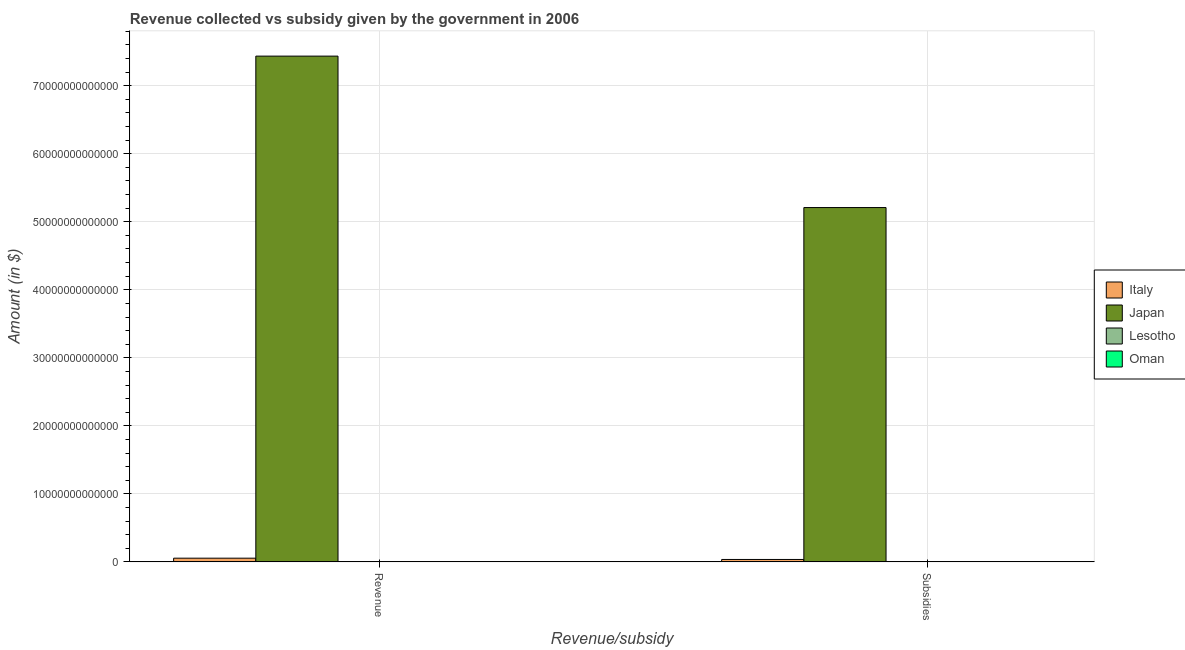How many different coloured bars are there?
Offer a terse response. 4. How many groups of bars are there?
Keep it short and to the point. 2. How many bars are there on the 1st tick from the left?
Offer a very short reply. 4. What is the label of the 1st group of bars from the left?
Offer a terse response. Revenue. What is the amount of subsidies given in Lesotho?
Offer a very short reply. 6.32e+08. Across all countries, what is the maximum amount of revenue collected?
Make the answer very short. 7.44e+13. Across all countries, what is the minimum amount of revenue collected?
Keep it short and to the point. 4.91e+09. In which country was the amount of subsidies given minimum?
Your response must be concise. Oman. What is the total amount of revenue collected in the graph?
Your answer should be very brief. 7.49e+13. What is the difference between the amount of revenue collected in Lesotho and that in Japan?
Offer a terse response. -7.43e+13. What is the difference between the amount of revenue collected in Japan and the amount of subsidies given in Oman?
Your response must be concise. 7.44e+13. What is the average amount of subsidies given per country?
Make the answer very short. 1.31e+13. What is the difference between the amount of revenue collected and amount of subsidies given in Oman?
Ensure brevity in your answer.  4.61e+09. What is the ratio of the amount of subsidies given in Oman to that in Japan?
Keep it short and to the point. 5.866701477809816e-6. Is the amount of subsidies given in Lesotho less than that in Japan?
Give a very brief answer. Yes. In how many countries, is the amount of subsidies given greater than the average amount of subsidies given taken over all countries?
Provide a short and direct response. 1. What does the 3rd bar from the left in Subsidies represents?
Keep it short and to the point. Lesotho. What does the 2nd bar from the right in Revenue represents?
Your answer should be very brief. Lesotho. How many bars are there?
Provide a succinct answer. 8. What is the difference between two consecutive major ticks on the Y-axis?
Provide a succinct answer. 1.00e+13. Does the graph contain any zero values?
Your answer should be compact. No. Does the graph contain grids?
Your response must be concise. Yes. Where does the legend appear in the graph?
Ensure brevity in your answer.  Center right. What is the title of the graph?
Your answer should be very brief. Revenue collected vs subsidy given by the government in 2006. Does "European Union" appear as one of the legend labels in the graph?
Give a very brief answer. No. What is the label or title of the X-axis?
Give a very brief answer. Revenue/subsidy. What is the label or title of the Y-axis?
Your answer should be very brief. Amount (in $). What is the Amount (in $) of Italy in Revenue?
Your answer should be compact. 5.47e+11. What is the Amount (in $) of Japan in Revenue?
Keep it short and to the point. 7.44e+13. What is the Amount (in $) of Lesotho in Revenue?
Your answer should be very brief. 6.49e+09. What is the Amount (in $) in Oman in Revenue?
Give a very brief answer. 4.91e+09. What is the Amount (in $) of Italy in Subsidies?
Your answer should be compact. 3.59e+11. What is the Amount (in $) of Japan in Subsidies?
Provide a short and direct response. 5.21e+13. What is the Amount (in $) of Lesotho in Subsidies?
Your answer should be compact. 6.32e+08. What is the Amount (in $) of Oman in Subsidies?
Give a very brief answer. 3.06e+08. Across all Revenue/subsidy, what is the maximum Amount (in $) in Italy?
Your answer should be very brief. 5.47e+11. Across all Revenue/subsidy, what is the maximum Amount (in $) in Japan?
Keep it short and to the point. 7.44e+13. Across all Revenue/subsidy, what is the maximum Amount (in $) of Lesotho?
Provide a short and direct response. 6.49e+09. Across all Revenue/subsidy, what is the maximum Amount (in $) of Oman?
Provide a succinct answer. 4.91e+09. Across all Revenue/subsidy, what is the minimum Amount (in $) of Italy?
Provide a short and direct response. 3.59e+11. Across all Revenue/subsidy, what is the minimum Amount (in $) of Japan?
Your answer should be very brief. 5.21e+13. Across all Revenue/subsidy, what is the minimum Amount (in $) of Lesotho?
Provide a short and direct response. 6.32e+08. Across all Revenue/subsidy, what is the minimum Amount (in $) of Oman?
Offer a very short reply. 3.06e+08. What is the total Amount (in $) in Italy in the graph?
Make the answer very short. 9.06e+11. What is the total Amount (in $) of Japan in the graph?
Ensure brevity in your answer.  1.26e+14. What is the total Amount (in $) in Lesotho in the graph?
Ensure brevity in your answer.  7.12e+09. What is the total Amount (in $) in Oman in the graph?
Your answer should be compact. 5.22e+09. What is the difference between the Amount (in $) in Italy in Revenue and that in Subsidies?
Give a very brief answer. 1.88e+11. What is the difference between the Amount (in $) in Japan in Revenue and that in Subsidies?
Keep it short and to the point. 2.23e+13. What is the difference between the Amount (in $) in Lesotho in Revenue and that in Subsidies?
Your answer should be very brief. 5.86e+09. What is the difference between the Amount (in $) in Oman in Revenue and that in Subsidies?
Offer a very short reply. 4.61e+09. What is the difference between the Amount (in $) in Italy in Revenue and the Amount (in $) in Japan in Subsidies?
Provide a short and direct response. -5.15e+13. What is the difference between the Amount (in $) of Italy in Revenue and the Amount (in $) of Lesotho in Subsidies?
Provide a short and direct response. 5.46e+11. What is the difference between the Amount (in $) in Italy in Revenue and the Amount (in $) in Oman in Subsidies?
Provide a succinct answer. 5.47e+11. What is the difference between the Amount (in $) of Japan in Revenue and the Amount (in $) of Lesotho in Subsidies?
Provide a succinct answer. 7.44e+13. What is the difference between the Amount (in $) of Japan in Revenue and the Amount (in $) of Oman in Subsidies?
Provide a short and direct response. 7.44e+13. What is the difference between the Amount (in $) in Lesotho in Revenue and the Amount (in $) in Oman in Subsidies?
Offer a very short reply. 6.18e+09. What is the average Amount (in $) in Italy per Revenue/subsidy?
Offer a very short reply. 4.53e+11. What is the average Amount (in $) in Japan per Revenue/subsidy?
Your response must be concise. 6.32e+13. What is the average Amount (in $) in Lesotho per Revenue/subsidy?
Give a very brief answer. 3.56e+09. What is the average Amount (in $) in Oman per Revenue/subsidy?
Offer a very short reply. 2.61e+09. What is the difference between the Amount (in $) of Italy and Amount (in $) of Japan in Revenue?
Ensure brevity in your answer.  -7.38e+13. What is the difference between the Amount (in $) in Italy and Amount (in $) in Lesotho in Revenue?
Make the answer very short. 5.40e+11. What is the difference between the Amount (in $) in Italy and Amount (in $) in Oman in Revenue?
Offer a terse response. 5.42e+11. What is the difference between the Amount (in $) in Japan and Amount (in $) in Lesotho in Revenue?
Offer a very short reply. 7.43e+13. What is the difference between the Amount (in $) of Japan and Amount (in $) of Oman in Revenue?
Make the answer very short. 7.43e+13. What is the difference between the Amount (in $) of Lesotho and Amount (in $) of Oman in Revenue?
Your answer should be compact. 1.57e+09. What is the difference between the Amount (in $) in Italy and Amount (in $) in Japan in Subsidies?
Give a very brief answer. -5.17e+13. What is the difference between the Amount (in $) in Italy and Amount (in $) in Lesotho in Subsidies?
Provide a short and direct response. 3.58e+11. What is the difference between the Amount (in $) in Italy and Amount (in $) in Oman in Subsidies?
Your answer should be compact. 3.59e+11. What is the difference between the Amount (in $) of Japan and Amount (in $) of Lesotho in Subsidies?
Provide a short and direct response. 5.21e+13. What is the difference between the Amount (in $) of Japan and Amount (in $) of Oman in Subsidies?
Your response must be concise. 5.21e+13. What is the difference between the Amount (in $) in Lesotho and Amount (in $) in Oman in Subsidies?
Provide a succinct answer. 3.26e+08. What is the ratio of the Amount (in $) of Italy in Revenue to that in Subsidies?
Keep it short and to the point. 1.52. What is the ratio of the Amount (in $) of Japan in Revenue to that in Subsidies?
Provide a short and direct response. 1.43. What is the ratio of the Amount (in $) of Lesotho in Revenue to that in Subsidies?
Provide a short and direct response. 10.27. What is the ratio of the Amount (in $) of Oman in Revenue to that in Subsidies?
Make the answer very short. 16.08. What is the difference between the highest and the second highest Amount (in $) in Italy?
Your response must be concise. 1.88e+11. What is the difference between the highest and the second highest Amount (in $) of Japan?
Give a very brief answer. 2.23e+13. What is the difference between the highest and the second highest Amount (in $) in Lesotho?
Your response must be concise. 5.86e+09. What is the difference between the highest and the second highest Amount (in $) of Oman?
Your response must be concise. 4.61e+09. What is the difference between the highest and the lowest Amount (in $) of Italy?
Your response must be concise. 1.88e+11. What is the difference between the highest and the lowest Amount (in $) of Japan?
Keep it short and to the point. 2.23e+13. What is the difference between the highest and the lowest Amount (in $) of Lesotho?
Give a very brief answer. 5.86e+09. What is the difference between the highest and the lowest Amount (in $) in Oman?
Your answer should be compact. 4.61e+09. 